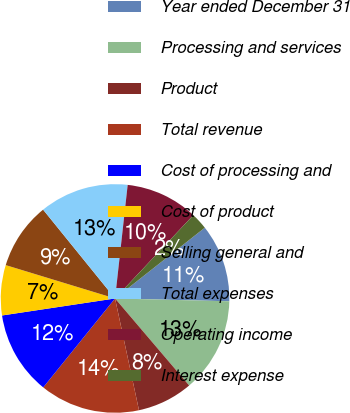Convert chart to OTSL. <chart><loc_0><loc_0><loc_500><loc_500><pie_chart><fcel>Year ended December 31<fcel>Processing and services<fcel>Product<fcel>Total revenue<fcel>Cost of processing and<fcel>Cost of product<fcel>Selling general and<fcel>Total expenses<fcel>Operating income<fcel>Interest expense<nl><fcel>11.02%<fcel>13.38%<fcel>7.87%<fcel>14.17%<fcel>11.81%<fcel>7.09%<fcel>9.45%<fcel>12.6%<fcel>10.24%<fcel>2.37%<nl></chart> 